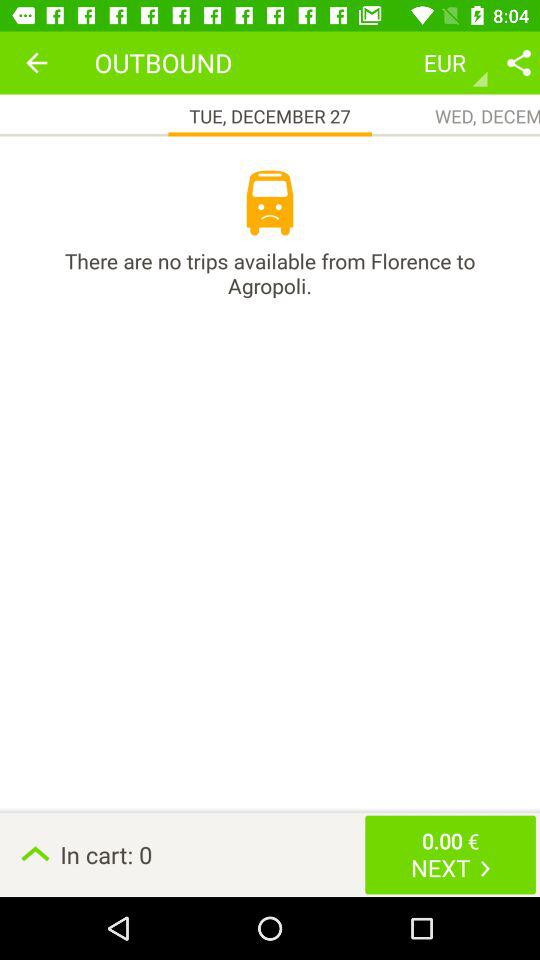Which tab is selected? The selected tab is "TUE, DECEMBER 27". 